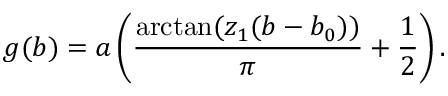Convert formula to latex. <formula><loc_0><loc_0><loc_500><loc_500>g ( b ) = a \left ( \frac { \arctan ( z _ { 1 } ( b - b _ { 0 } ) ) } { \pi } + \frac { 1 } { 2 } \right ) .</formula> 